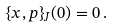Convert formula to latex. <formula><loc_0><loc_0><loc_500><loc_500>\{ x , p \} _ { J } ( 0 ) = 0 \, .</formula> 